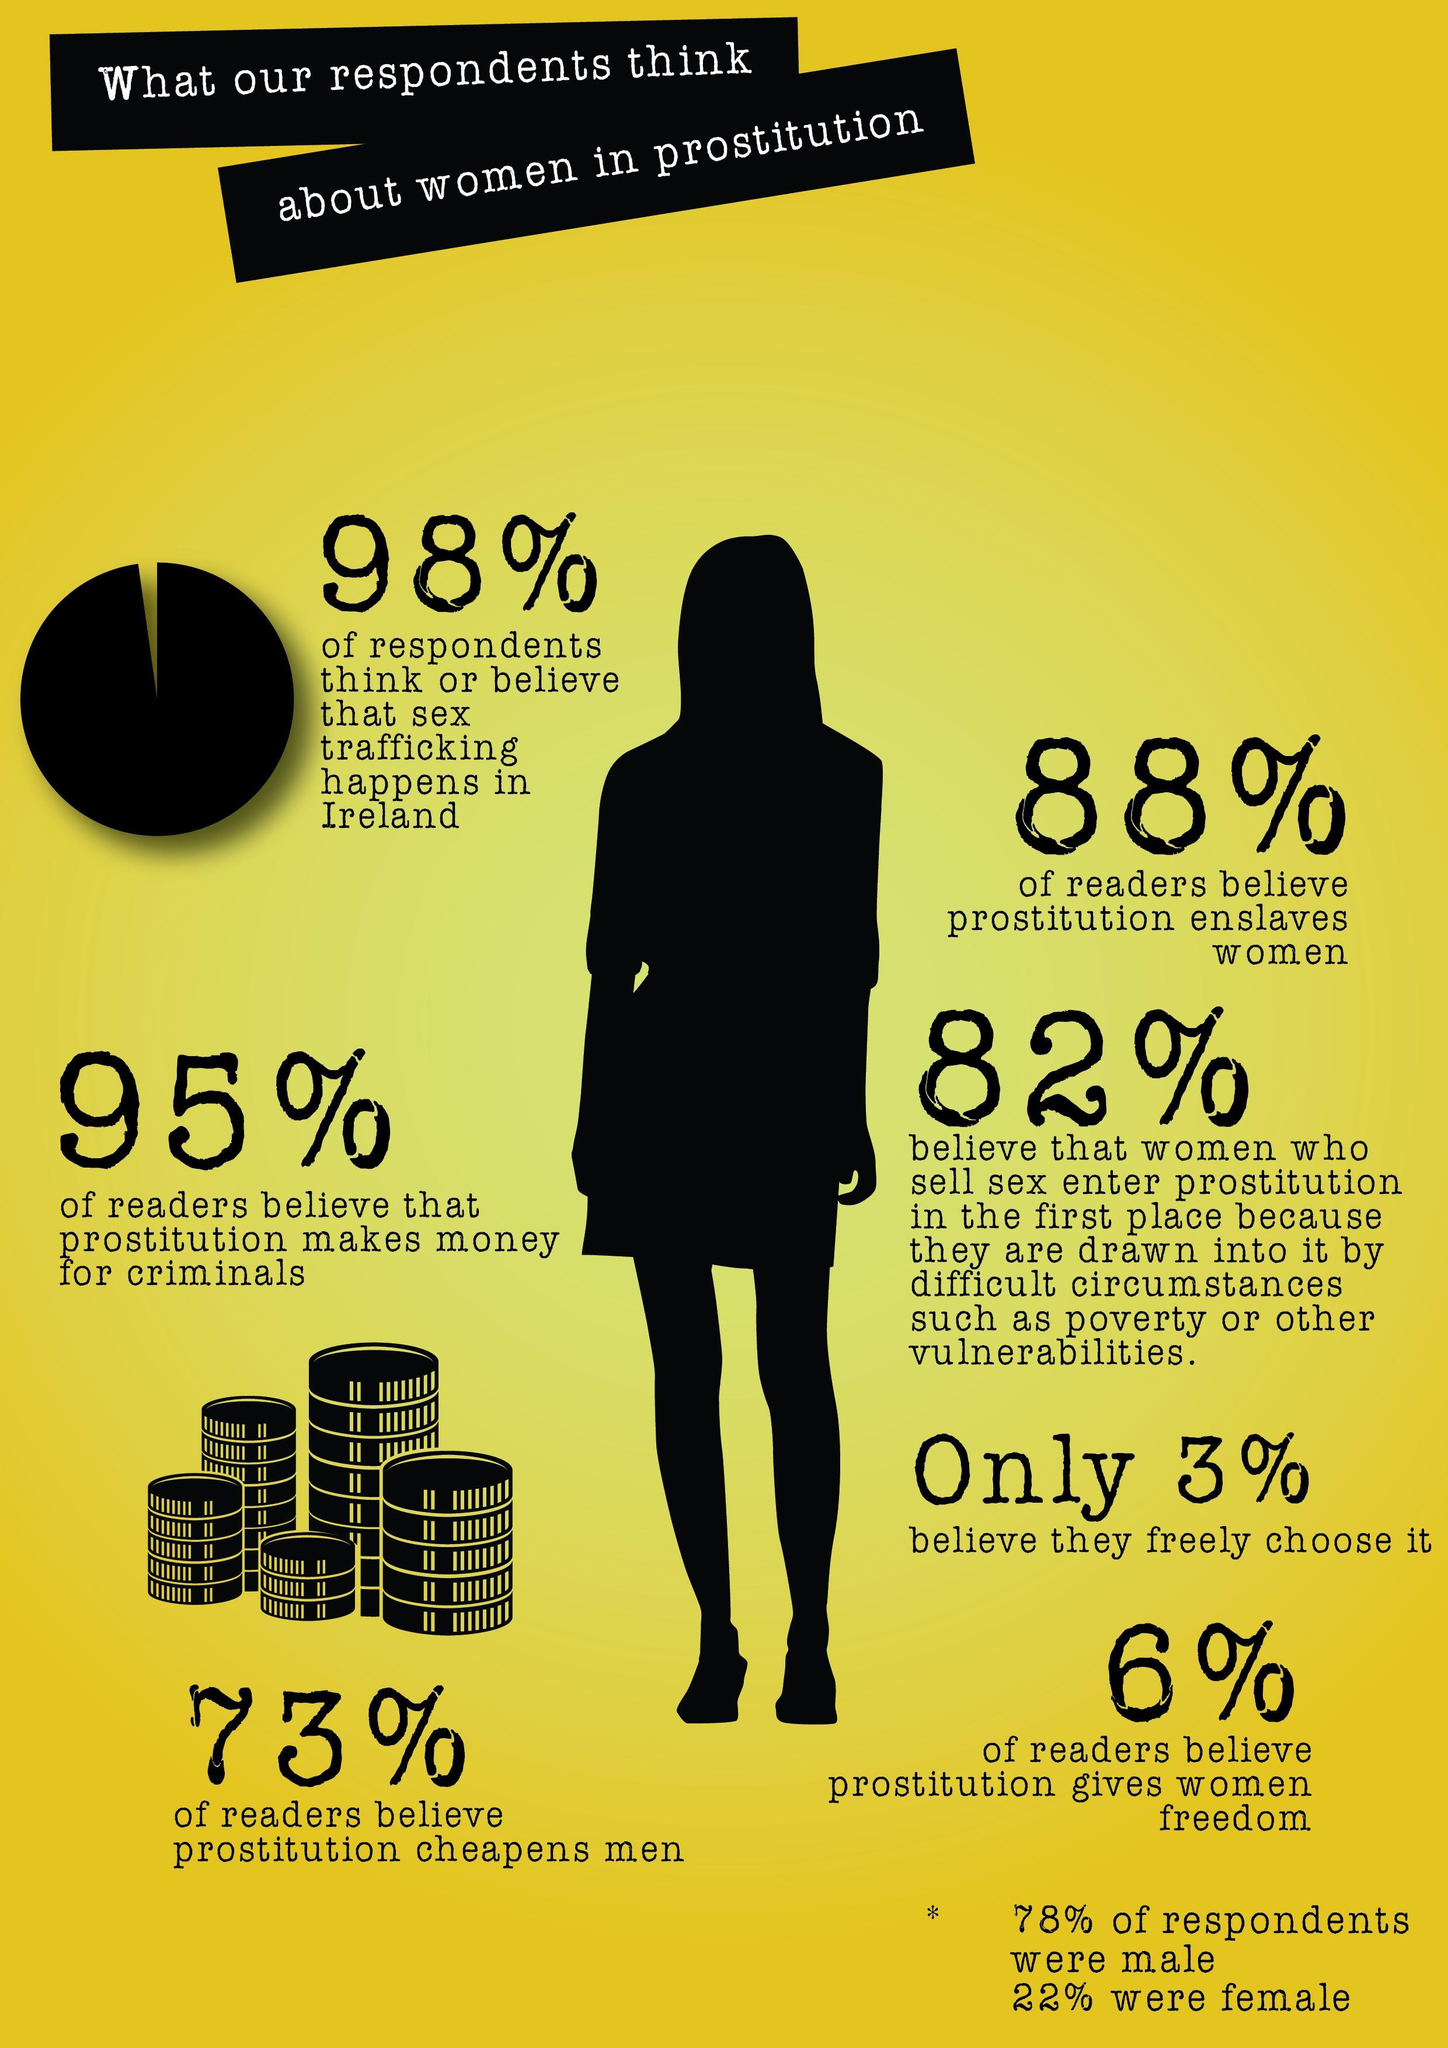What percentage of readers don't believe prostitution enslaves women?
Answer the question with a short phrase. 12% What percentage of readers don't believe prostitution cheapens men? 27% What percentage of readers don't believe prostitution makes money for criminals? 5% What percentage of respondents don't believe that sex trafficking happens in Ireland? 2% What percentage of readers don't believe prostitution gives women freedom? 94% 